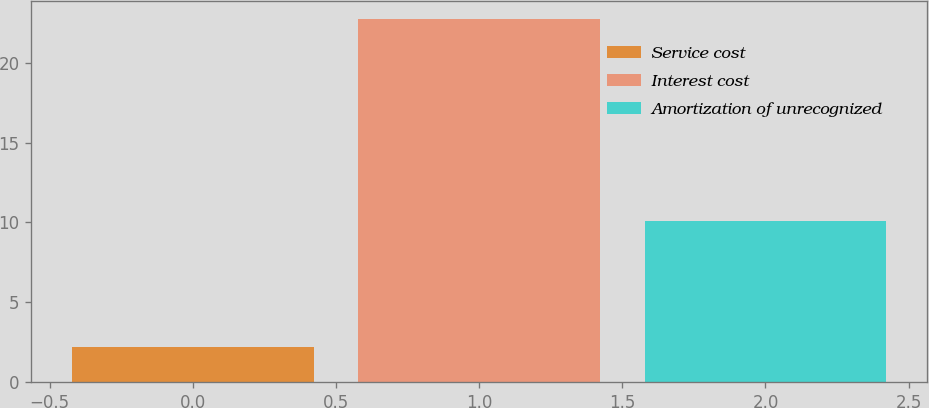Convert chart to OTSL. <chart><loc_0><loc_0><loc_500><loc_500><bar_chart><fcel>Service cost<fcel>Interest cost<fcel>Amortization of unrecognized<nl><fcel>2.2<fcel>22.7<fcel>10.1<nl></chart> 